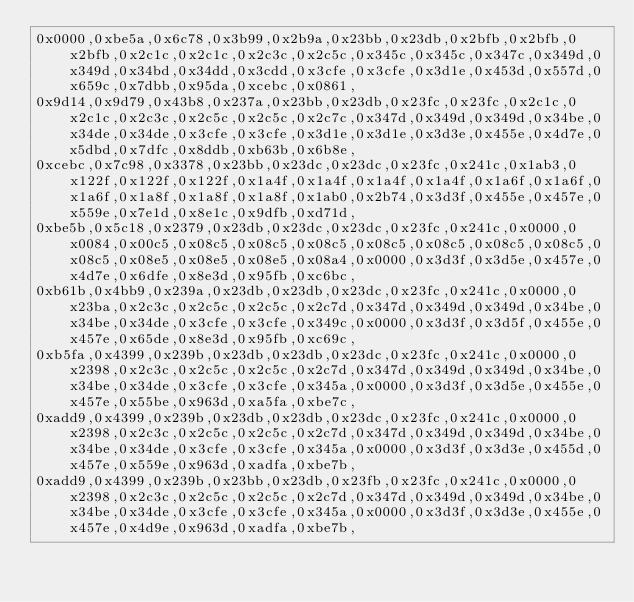Convert code to text. <code><loc_0><loc_0><loc_500><loc_500><_C_>0x0000,0xbe5a,0x6c78,0x3b99,0x2b9a,0x23bb,0x23db,0x2bfb,0x2bfb,0x2bfb,0x2c1c,0x2c1c,0x2c3c,0x2c5c,0x345c,0x345c,0x347c,0x349d,0x349d,0x34bd,0x34dd,0x3cdd,0x3cfe,0x3cfe,0x3d1e,0x453d,0x557d,0x659c,0x7dbb,0x95da,0xcebc,0x0861,
0x9d14,0x9d79,0x43b8,0x237a,0x23bb,0x23db,0x23fc,0x23fc,0x2c1c,0x2c1c,0x2c3c,0x2c5c,0x2c5c,0x2c7c,0x347d,0x349d,0x349d,0x34be,0x34de,0x34de,0x3cfe,0x3cfe,0x3d1e,0x3d1e,0x3d3e,0x455e,0x4d7e,0x5dbd,0x7dfc,0x8ddb,0xb63b,0x6b8e,
0xcebc,0x7c98,0x3378,0x23bb,0x23dc,0x23dc,0x23fc,0x241c,0x1ab3,0x122f,0x122f,0x122f,0x1a4f,0x1a4f,0x1a4f,0x1a4f,0x1a6f,0x1a6f,0x1a6f,0x1a8f,0x1a8f,0x1a8f,0x1ab0,0x2b74,0x3d3f,0x455e,0x457e,0x559e,0x7e1d,0x8e1c,0x9dfb,0xd71d,
0xbe5b,0x5c18,0x2379,0x23db,0x23dc,0x23dc,0x23fc,0x241c,0x0000,0x0084,0x00c5,0x08c5,0x08c5,0x08c5,0x08c5,0x08c5,0x08c5,0x08c5,0x08c5,0x08e5,0x08e5,0x08e5,0x08a4,0x0000,0x3d3f,0x3d5e,0x457e,0x4d7e,0x6dfe,0x8e3d,0x95fb,0xc6bc,
0xb61b,0x4bb9,0x239a,0x23db,0x23db,0x23dc,0x23fc,0x241c,0x0000,0x23ba,0x2c3c,0x2c5c,0x2c5c,0x2c7d,0x347d,0x349d,0x349d,0x34be,0x34be,0x34de,0x3cfe,0x3cfe,0x349c,0x0000,0x3d3f,0x3d5f,0x455e,0x457e,0x65de,0x8e3d,0x95fb,0xc69c,
0xb5fa,0x4399,0x239b,0x23db,0x23db,0x23dc,0x23fc,0x241c,0x0000,0x2398,0x2c3c,0x2c5c,0x2c5c,0x2c7d,0x347d,0x349d,0x349d,0x34be,0x34be,0x34de,0x3cfe,0x3cfe,0x345a,0x0000,0x3d3f,0x3d5e,0x455e,0x457e,0x55be,0x963d,0xa5fa,0xbe7c,
0xadd9,0x4399,0x239b,0x23db,0x23db,0x23dc,0x23fc,0x241c,0x0000,0x2398,0x2c3c,0x2c5c,0x2c5c,0x2c7d,0x347d,0x349d,0x349d,0x34be,0x34be,0x34de,0x3cfe,0x3cfe,0x345a,0x0000,0x3d3f,0x3d3e,0x455d,0x457e,0x559e,0x963d,0xadfa,0xbe7b,
0xadd9,0x4399,0x239b,0x23bb,0x23db,0x23fb,0x23fc,0x241c,0x0000,0x2398,0x2c3c,0x2c5c,0x2c5c,0x2c7d,0x347d,0x349d,0x349d,0x34be,0x34be,0x34de,0x3cfe,0x3cfe,0x345a,0x0000,0x3d3f,0x3d3e,0x455e,0x457e,0x4d9e,0x963d,0xadfa,0xbe7b,</code> 